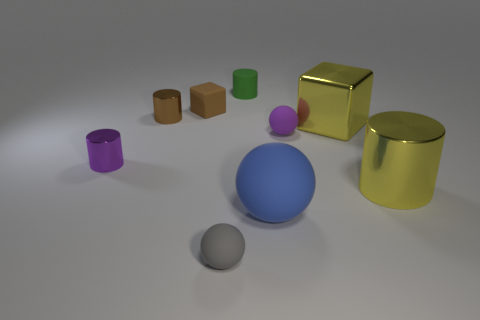Subtract all spheres. How many objects are left? 6 Add 5 big cyan objects. How many big cyan objects exist? 5 Subtract 0 red cubes. How many objects are left? 9 Subtract all tiny gray rubber objects. Subtract all large blue balls. How many objects are left? 7 Add 4 purple spheres. How many purple spheres are left? 5 